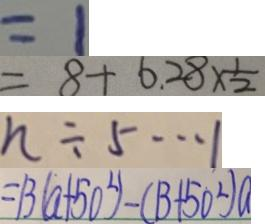Convert formula to latex. <formula><loc_0><loc_0><loc_500><loc_500>= 1 
 = 8 + 6 . 2 8 \times \frac { 1 } { 2 } 
 n \div 5 \cdots 1 
 = 1 3 ( a + 5 0 ^ { 2 } ) - ( 1 3 + 5 0 ^ { 2 } ) a</formula> 